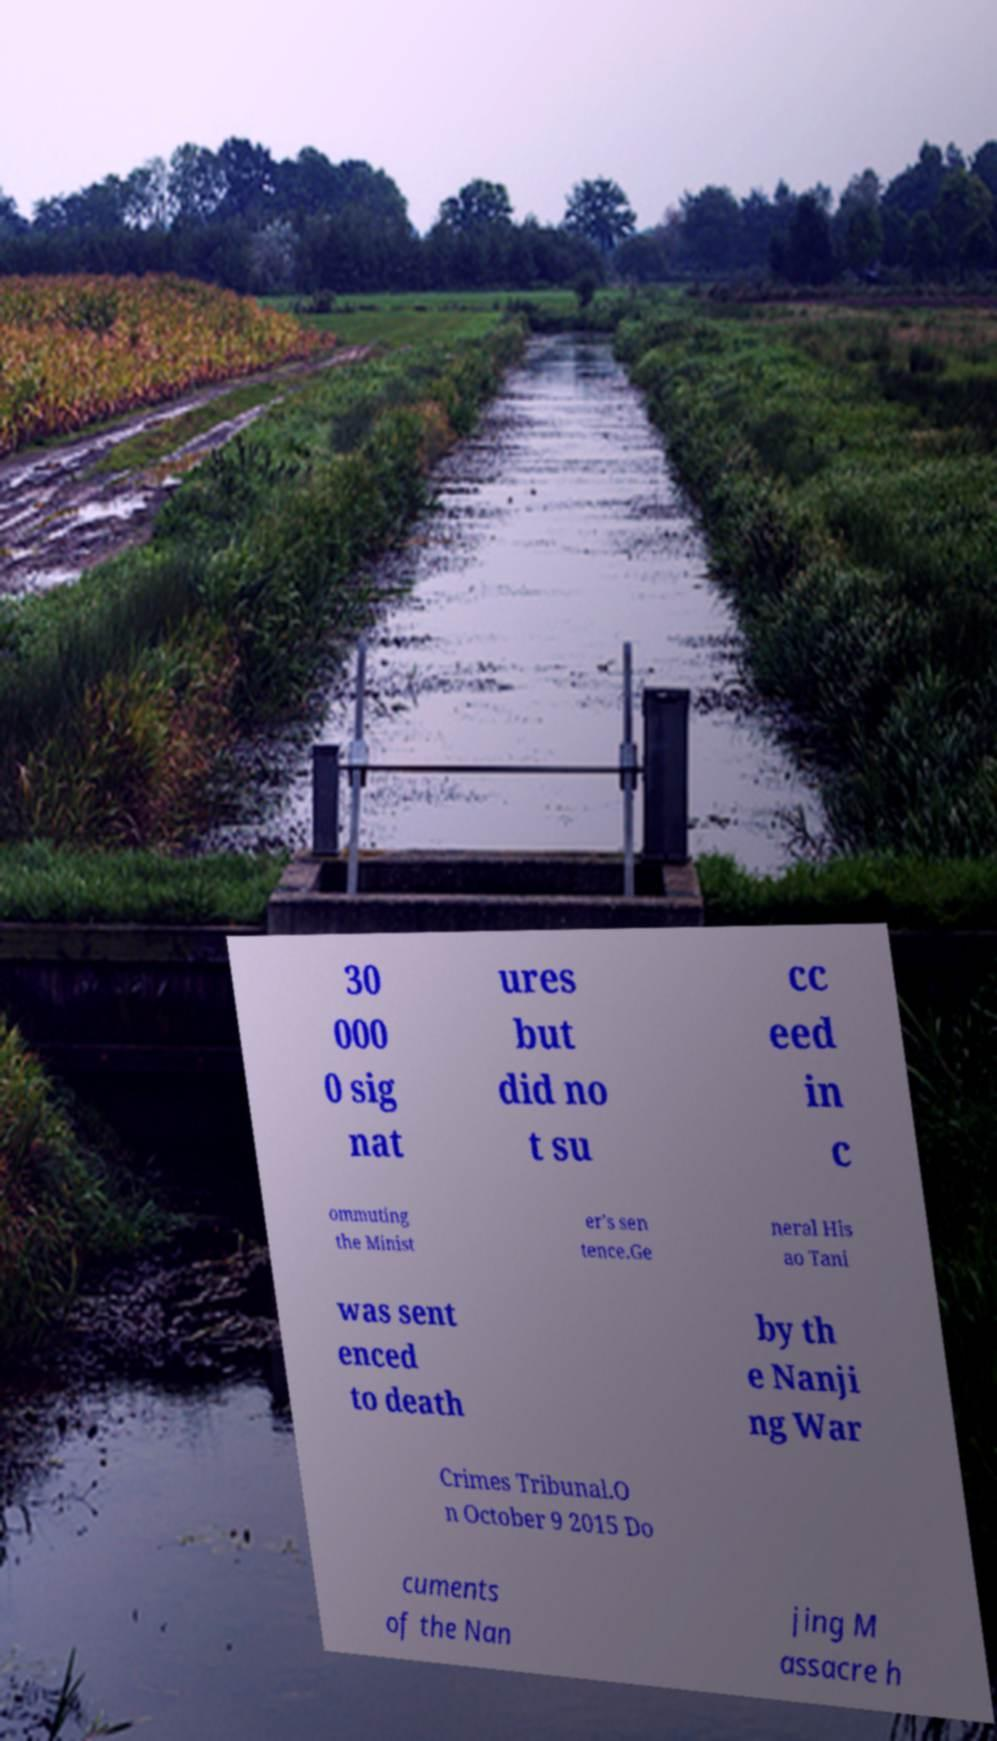Please identify and transcribe the text found in this image. 30 000 0 sig nat ures but did no t su cc eed in c ommuting the Minist er's sen tence.Ge neral His ao Tani was sent enced to death by th e Nanji ng War Crimes Tribunal.O n October 9 2015 Do cuments of the Nan jing M assacre h 